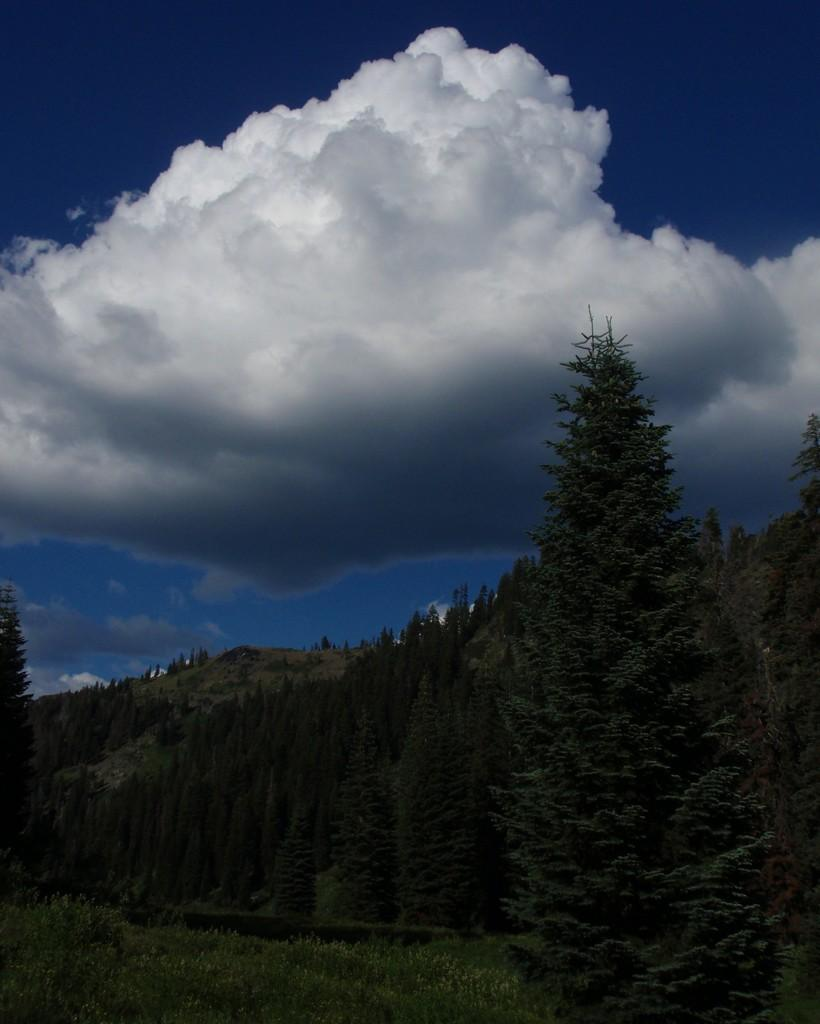What type of vegetation is present at the bottom of the image? There are trees at the bottom of the image. What geographical feature is also present at the bottom of the image? There is a hill at the bottom of the image. What can be seen in the sky at the top of the image? Clouds are visible at the top of the image. What else is visible in the sky at the top of the image? The sky is visible at the top of the image. What type of noise can be heard coming from the grain in the image? There is no grain present in the image, and therefore no such noise can be heard. 